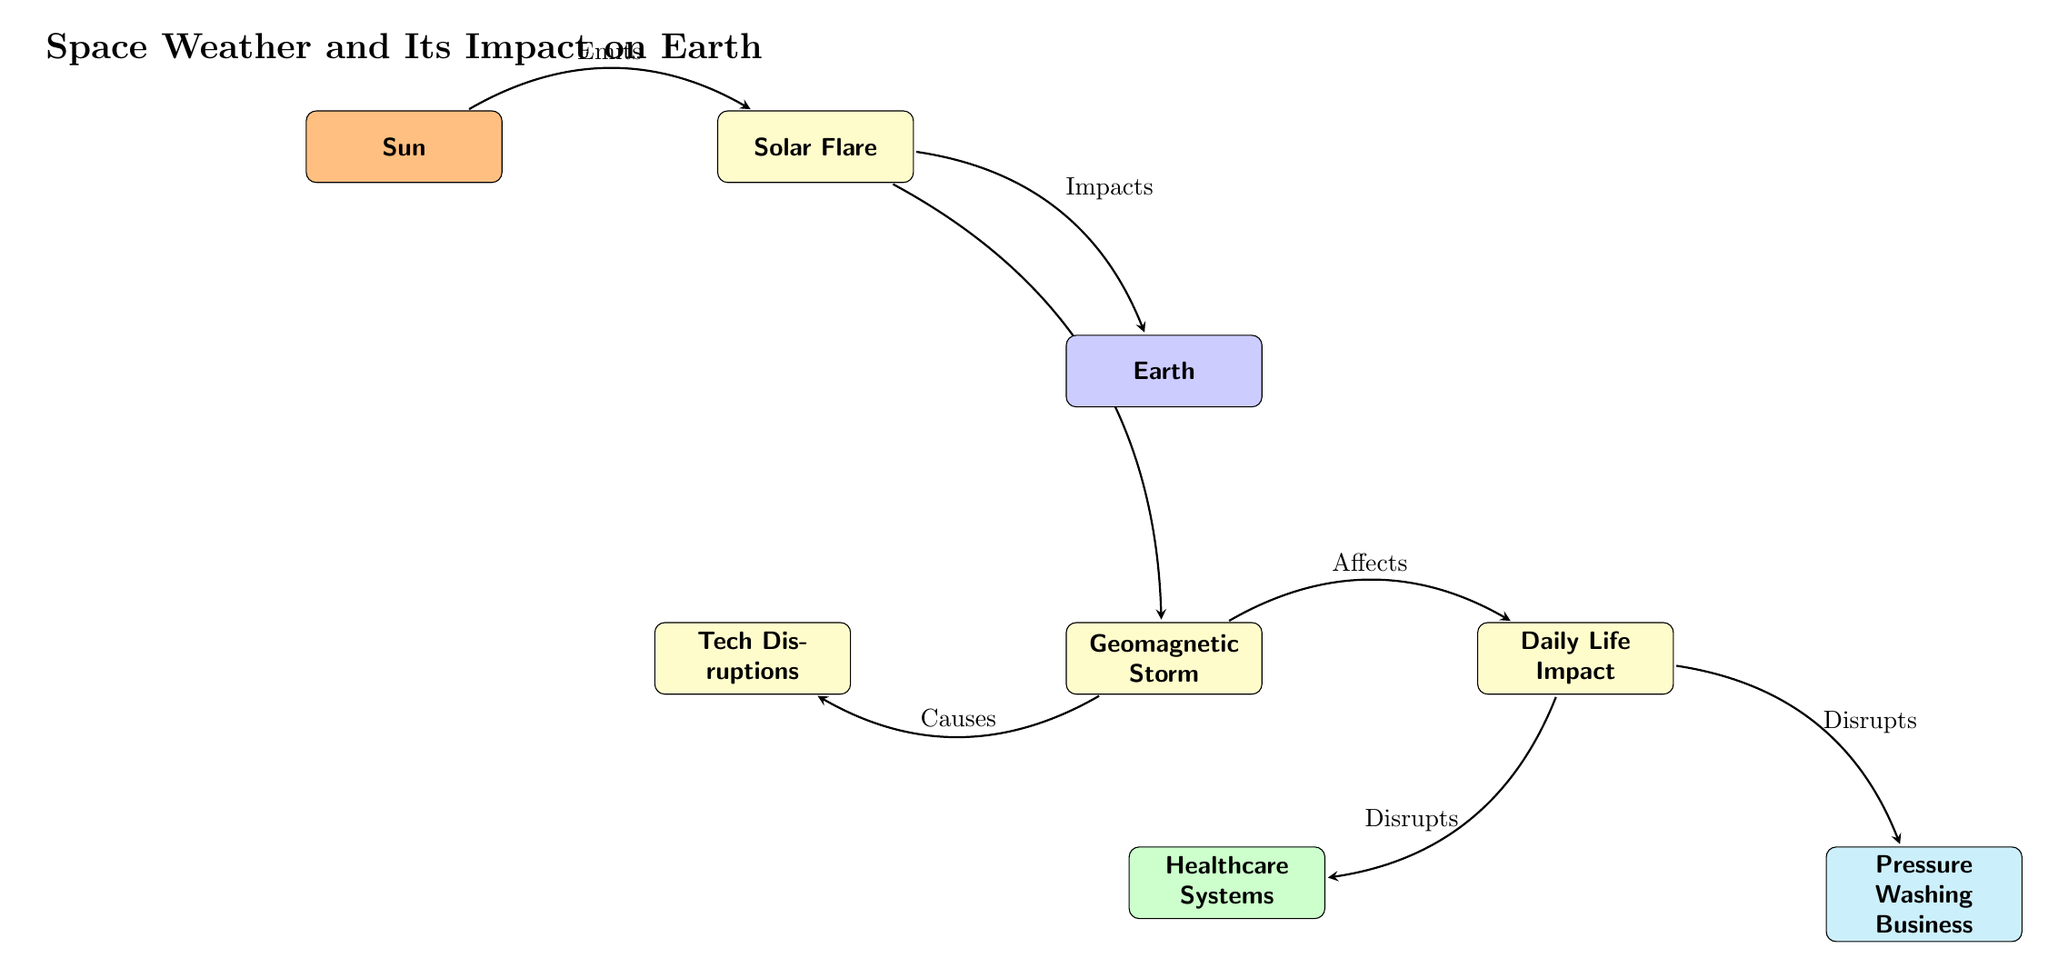What does the Sun emit? The diagram identifies the relationship between the Sun and solar flares, indicating that the Sun emits solar flares.
Answer: solar flares What effect do solar flares have on Earth? The arrow on the diagram points from solar flares to Earth, labeled "Impacts", showing that solar flares impact Earth.
Answer: Impacts What triggers geomagnetic storms? The arrow from solar flares to geomagnetic storms in the diagram is labeled "Triggers", which shows that solar flares trigger geomagnetic storms.
Answer: solar flares How many impacts does geomagnetic storms have? The diagram shows two effects from geomagnetic storms: tech disruptions and daily life impact, indicating that there are two impacts.
Answer: 2 What is affected by daily life disruptions? The diagram has arrows leading from daily life to nursing and pressure washing, showing that nursing and pressure washing are both disrupted by daily life.
Answer: nursing and pressure washing What does geomagnetic storms cause? According to the diagram, geomagnetic storms cause tech disruptions, as indicated by the arrow labeled "Causes".
Answer: Tech Disruptions Which diagram node shows the effect on healthcare systems? The node labeled "Healthcare Systems" is located below the node labeled "Daily Life Impact" and is colored green, indicating that it shows the effect on healthcare systems.
Answer: Healthcare Systems Explain how solar flares influence daily life. The diagram illustrates that solar flares impact Earth, which in turn affects daily life. This two-step flow shows that solar flares directly influence daily life through their impact on Earth.
Answer: Solar flares What color represents the Earth in the diagram? The node representing Earth is labeled in blue, indicating that blue is the color associated with Earth.
Answer: blue 